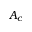Convert formula to latex. <formula><loc_0><loc_0><loc_500><loc_500>A _ { c }</formula> 